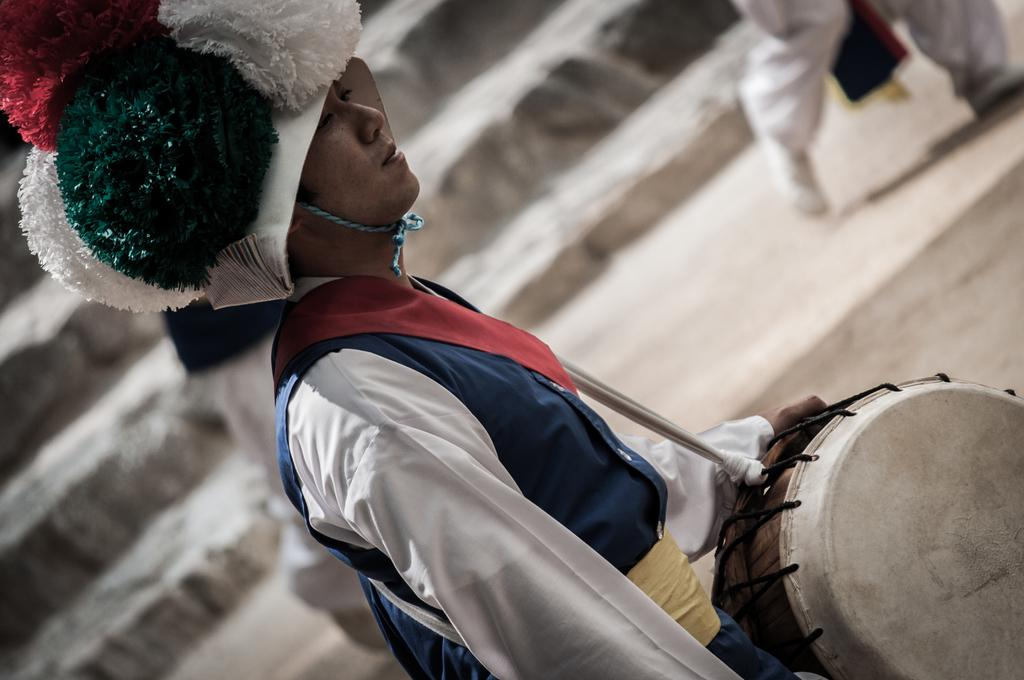Who are the subjects in the image? There are people in the image. What is one of the people doing in the image? A man is playing a drum in the image. What architectural feature can be seen in the background of the image? There are steps visible in the background of the image. Where is the horse located in the image? There is no horse present in the image. What type of mailbox can be seen near the steps in the image? There is no mailbox present in the image. 